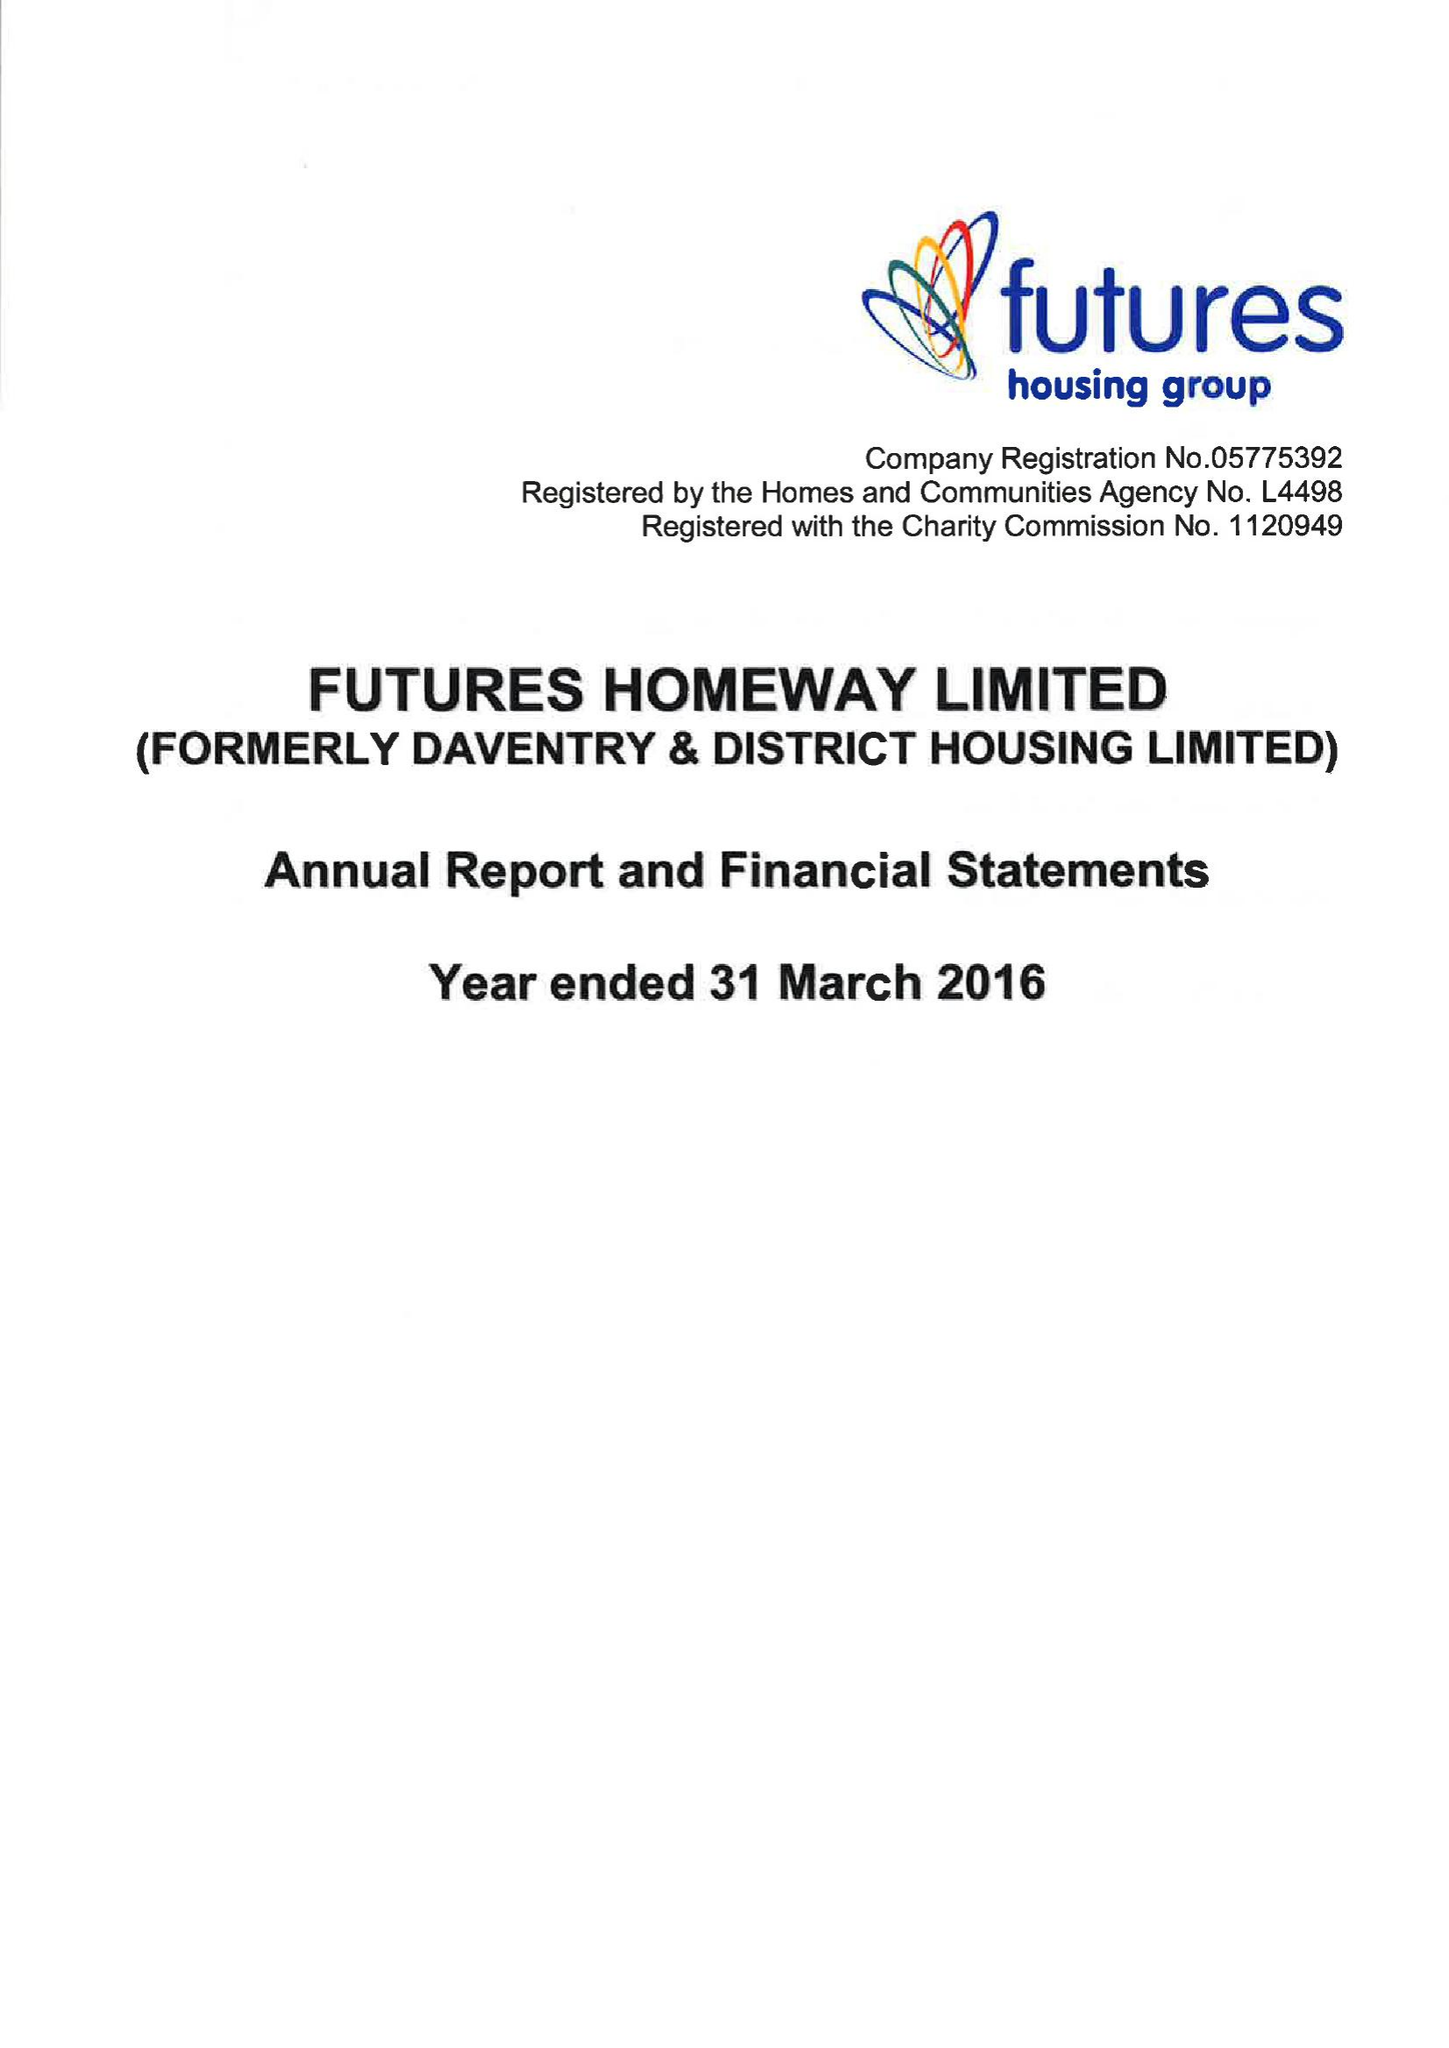What is the value for the address__postcode?
Answer the question using a single word or phrase. DE5 3SW 